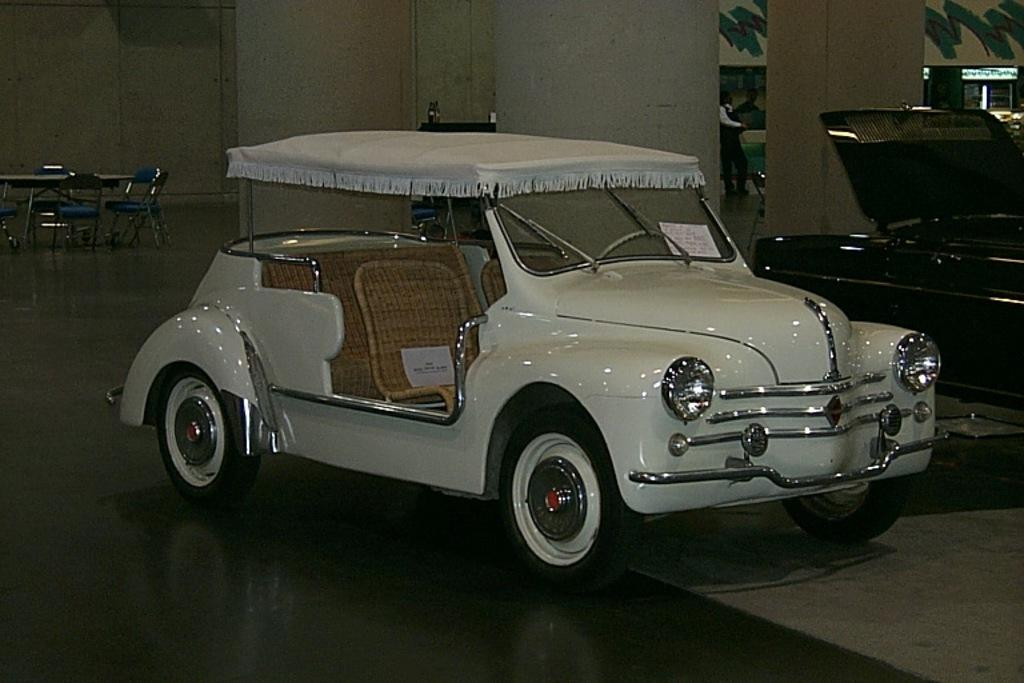What type of vehicles can be seen in the image? There are cars in the image. What furniture is located on the left side of the image? There are tables and chairs on the left side of the image. Can you describe the person in the image? There is a person standing in the middle of the image. What color is the car in the middle of the image? There is a white car in the middle of the image. What historical event is being celebrated in the image? There is no indication of a historical event being celebrated in the image. What reward is the person holding in the image? There is no reward visible in the image; the person is simply standing. 